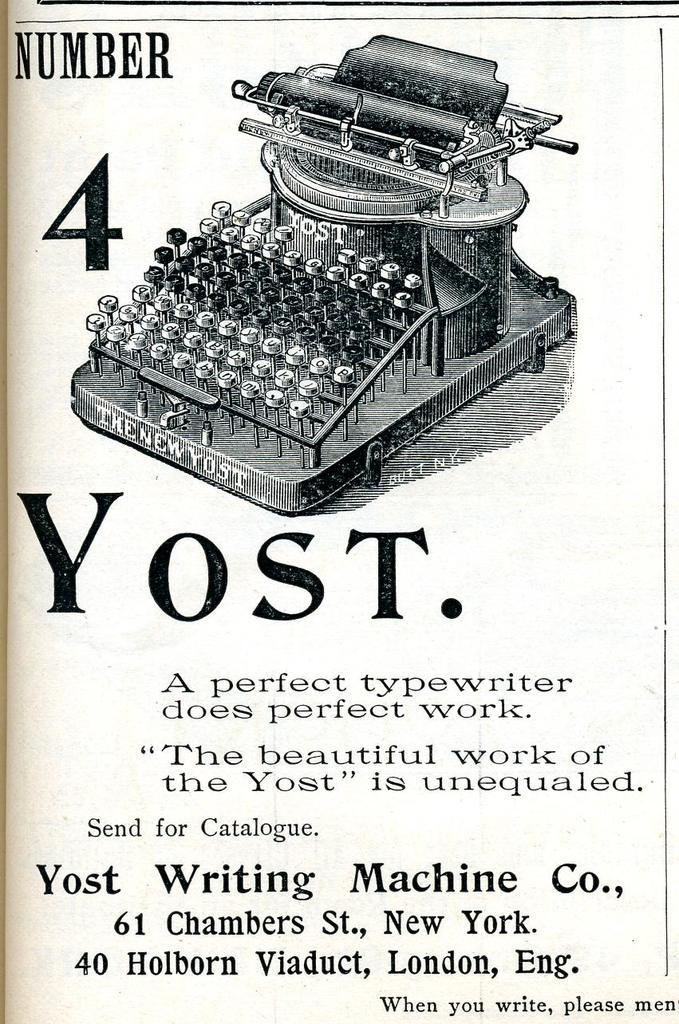<image>
Offer a succinct explanation of the picture presented. a paper that says 'yost.' on it underneath a typewriter. 